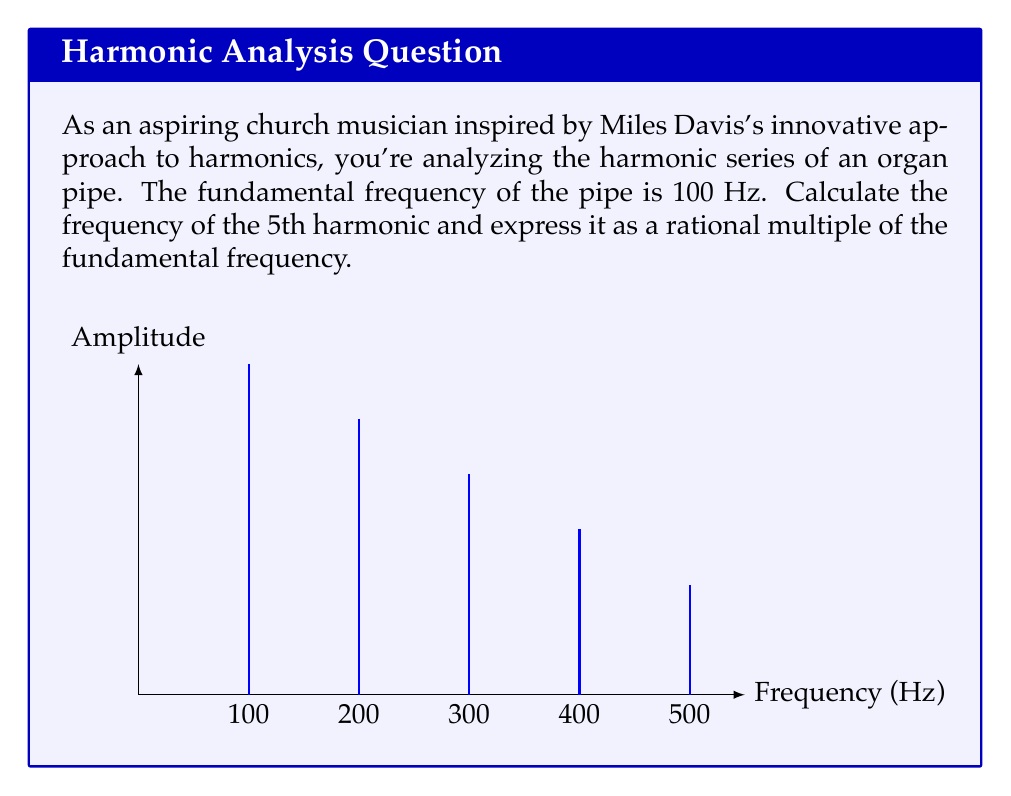Provide a solution to this math problem. Let's approach this step-by-step:

1) In a harmonic series, the frequency of each harmonic is an integer multiple of the fundamental frequency. We can express this mathematically as:

   $$f_n = n \cdot f_1$$

   Where $f_n$ is the frequency of the nth harmonic, and $f_1$ is the fundamental frequency.

2) We're given that the fundamental frequency ($f_1$) is 100 Hz.

3) We're asked to find the 5th harmonic, so n = 5.

4) Plugging these values into our equation:

   $$f_5 = 5 \cdot 100\text{ Hz} = 500\text{ Hz}$$

5) To express this as a rational multiple of the fundamental frequency:

   $$\frac{f_5}{f_1} = \frac{500\text{ Hz}}{100\text{ Hz}} = \frac{5}{1}$$

This rational number, 5/1, represents the relationship between the 5th harmonic and the fundamental frequency. It's a perfect example of the mathematical precision in music that might have intrigued Miles Davis in his explorations of harmony.
Answer: 500 Hz; $\frac{5}{1}$ times the fundamental frequency 